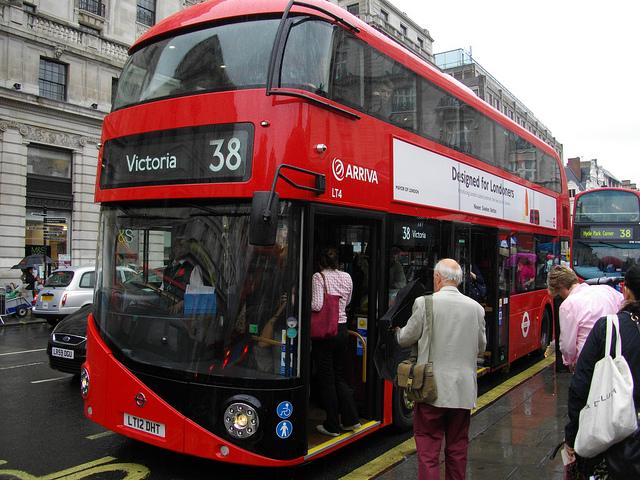Are there people boarding the bus?
Be succinct. Yes. What are the bags for?
Give a very brief answer. Carrying. Are people getting off the bus?
Keep it brief. No. In what country is this bus stop?
Keep it brief. England. 